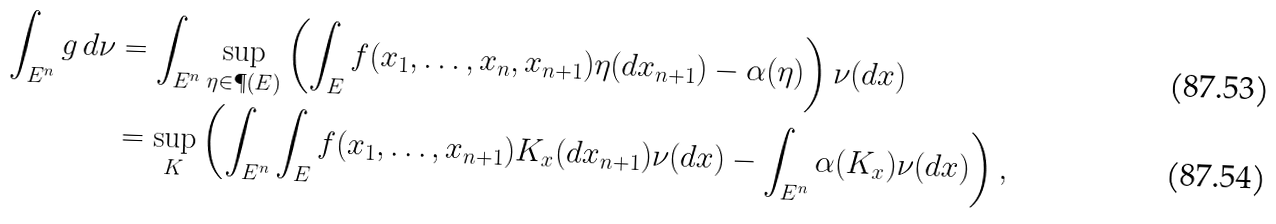Convert formula to latex. <formula><loc_0><loc_0><loc_500><loc_500>\int _ { E ^ { n } } g \, d \nu & = \int _ { E ^ { n } } \sup _ { \eta \in \P ( E ) } \left ( \int _ { E } f ( x _ { 1 } , \dots , x _ { n } , x _ { n + 1 } ) \eta ( d x _ { n + 1 } ) - \alpha ( \eta ) \right ) \nu ( d x ) \\ & = \sup _ { K } \left ( \int _ { E ^ { n } } \int _ { E } f ( x _ { 1 } , \dots , x _ { n + 1 } ) K _ { x } ( d x _ { n + 1 } ) \nu ( d x ) - \int _ { E ^ { n } } \alpha ( K _ { x } ) \nu ( d x ) \right ) ,</formula> 